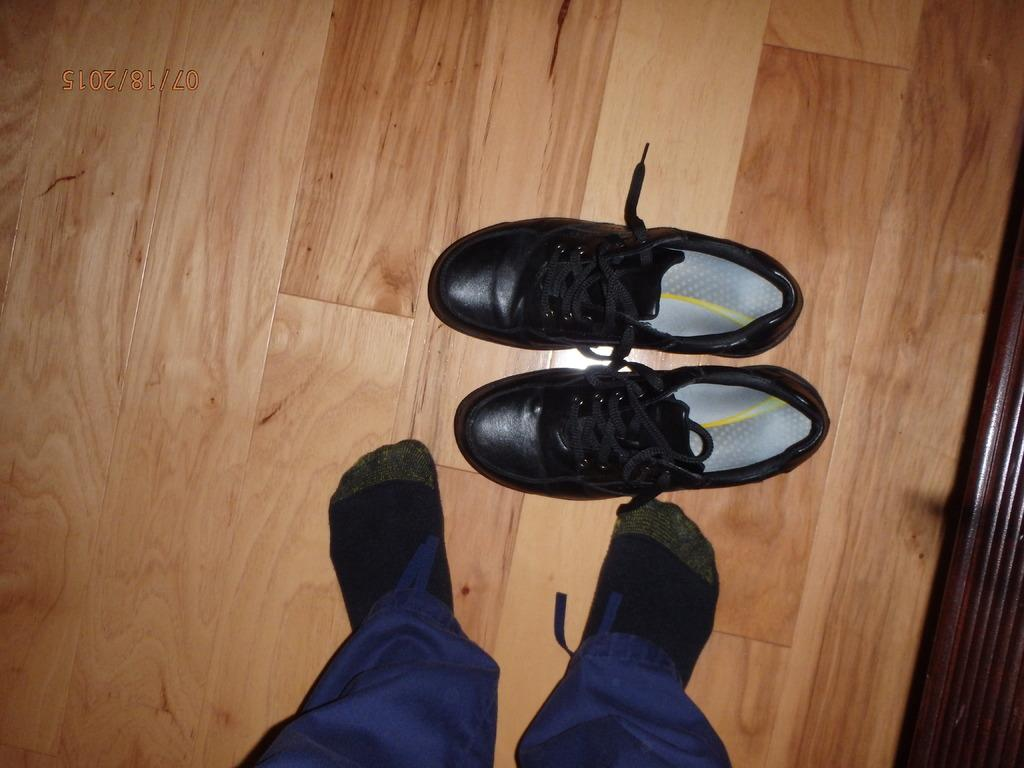What type of footwear is visible in the image? There are black shoes in the image. Can you describe the person standing in the image? There is a person standing on the floor in the image. What statement is written on the page held by the person in the image? There is no page or statement visible in the image; it only features a person standing and black shoes. 